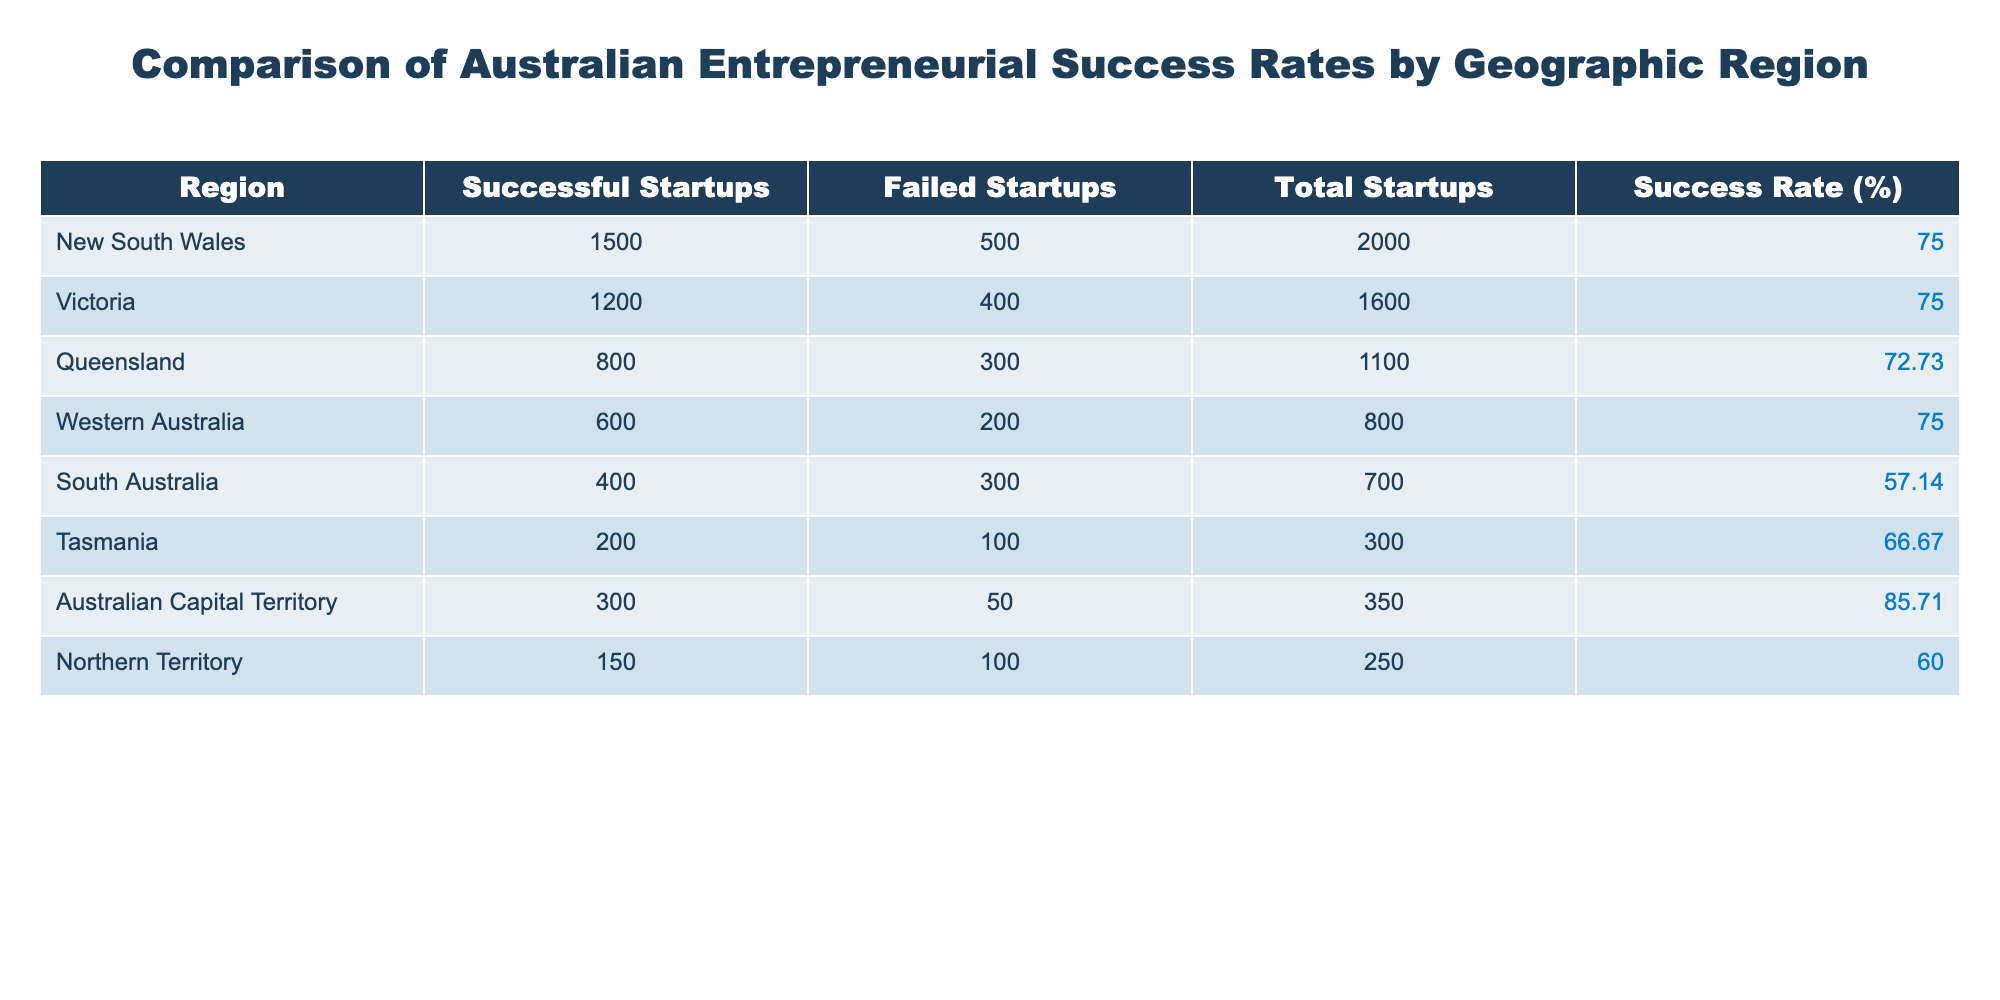What region has the highest success rate? By examining the success rate percentages in the table, Australian Capital Territory has a success rate of 85.71%, which is higher than any other region listed.
Answer: Australian Capital Territory What is the total number of successful startups in Victoria? The table indicates that Victoria has 1,200 successful startups, as listed in the third column.
Answer: 1200 Which region has the lowest success rate? South Australia has the lowest success rate at 57.14%. This is identified by comparing all success rates in the table.
Answer: South Australia How many total startups are there in New South Wales and Queensland combined? To find the total startups in New South Wales (2,000) and Queensland (1,100), they are added together: 2000 + 1100 = 3100.
Answer: 3100 Does Queensland have a success rate higher than South Australia? The success rate for Queensland is 72.73%, while South Australia has a success rate of 57.14%. Since 72.73 is greater than 57.14, the statement is true.
Answer: Yes What is the average success rate of all regions? To find the average success rate, sum all the success rates (75 + 75 + 72.73 + 75 + 57.14 + 66.67 + 85.71 + 60) =  588.25. Divide this by the number of regions (8): 588.25 / 8 = 73.53.
Answer: 73.53 Which region has more failed startups, Tasmania or Northern Territory? Tasmania has 100 failed startups, while Northern Territory has 100 failed startups too. Since both values are equal, neither region has more failed startups.
Answer: They are equal What is the difference in the number of successful startups between New South Wales and South Australia? New South Wales has 1,500 successful startups, and South Australia has 400. The difference is calculated by subtracting: 1500 - 400 = 1100.
Answer: 1100 Is the number of failed startups in Western Australia greater than that in Northern Territory? Western Australia has 200 failed startups, while Northern Territory has 100 failed startups. Since 200 is greater than 100, the answer is yes.
Answer: Yes 